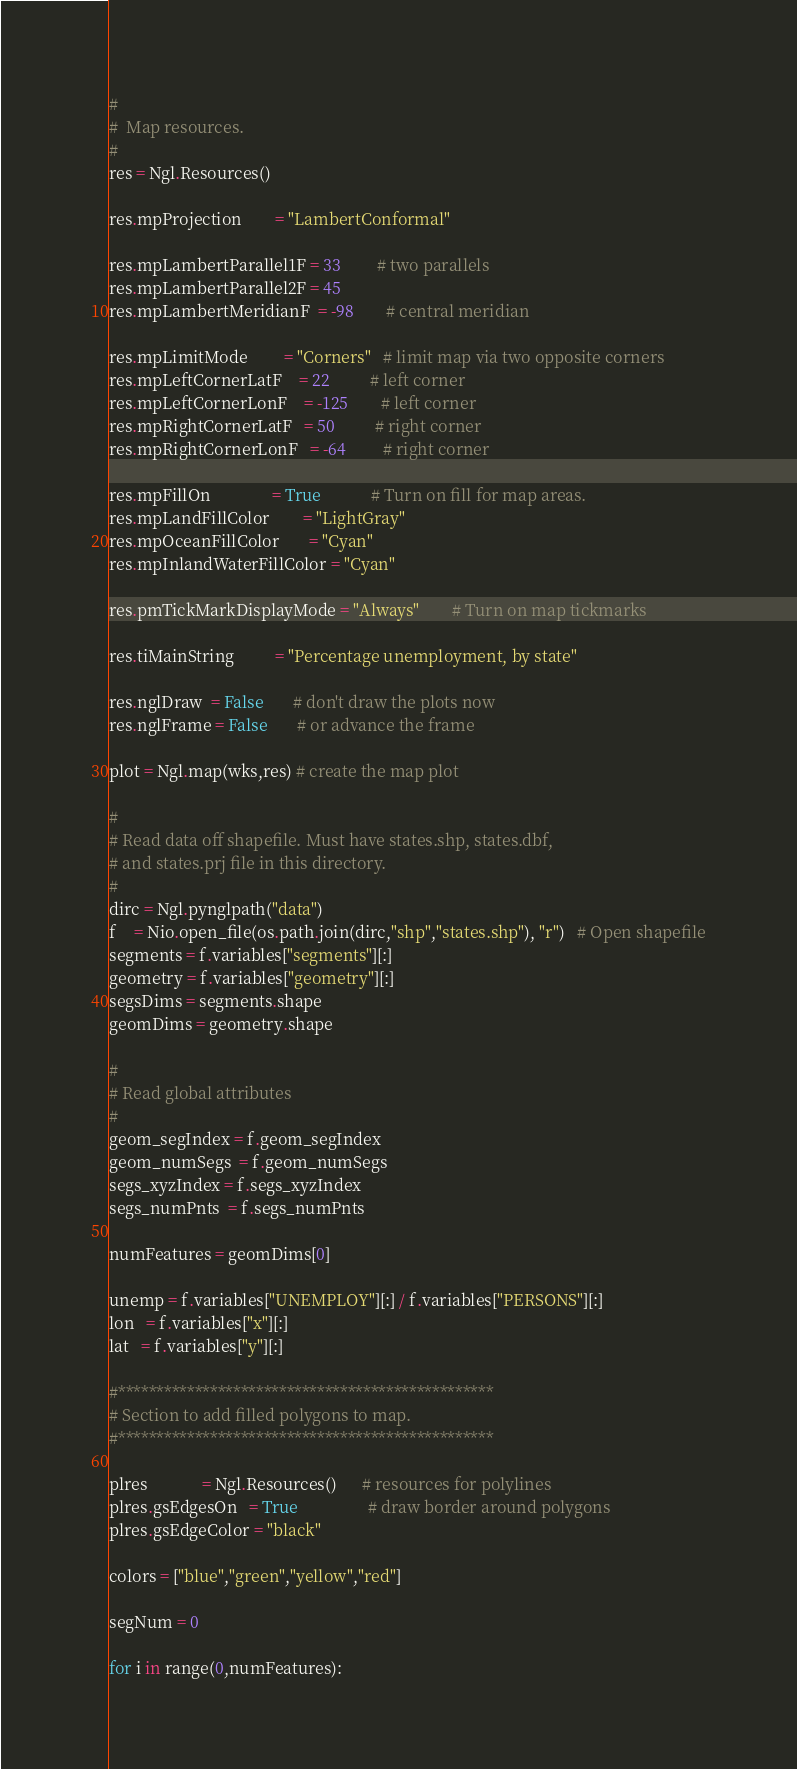<code> <loc_0><loc_0><loc_500><loc_500><_Python_>
#
#  Map resources.
#
res = Ngl.Resources()

res.mpProjection        = "LambertConformal"

res.mpLambertParallel1F = 33         # two parallels
res.mpLambertParallel2F = 45
res.mpLambertMeridianF  = -98        # central meridian

res.mpLimitMode         = "Corners"   # limit map via two opposite corners
res.mpLeftCornerLatF    = 22          # left corner
res.mpLeftCornerLonF    = -125        # left corner
res.mpRightCornerLatF   = 50          # right corner
res.mpRightCornerLonF   = -64         # right corner

res.mpFillOn               = True            # Turn on fill for map areas.
res.mpLandFillColor        = "LightGray"
res.mpOceanFillColor       = "Cyan"
res.mpInlandWaterFillColor = "Cyan"

res.pmTickMarkDisplayMode = "Always"        # Turn on map tickmarks

res.tiMainString          = "Percentage unemployment, by state"

res.nglDraw  = False       # don't draw the plots now
res.nglFrame = False       # or advance the frame

plot = Ngl.map(wks,res) # create the map plot

#
# Read data off shapefile. Must have states.shp, states.dbf,
# and states.prj file in this directory.
#
dirc = Ngl.pynglpath("data")
f    = Nio.open_file(os.path.join(dirc,"shp","states.shp"), "r")   # Open shapefile
segments = f.variables["segments"][:]
geometry = f.variables["geometry"][:]
segsDims = segments.shape
geomDims = geometry.shape

#
# Read global attributes  
#
geom_segIndex = f.geom_segIndex
geom_numSegs  = f.geom_numSegs
segs_xyzIndex = f.segs_xyzIndex
segs_numPnts  = f.segs_numPnts

numFeatures = geomDims[0]

unemp = f.variables["UNEMPLOY"][:] / f.variables["PERSONS"][:]
lon   = f.variables["x"][:]
lat   = f.variables["y"][:]

#*************************************************
# Section to add filled polygons to map.
#*************************************************

plres             = Ngl.Resources()      # resources for polylines
plres.gsEdgesOn   = True                 # draw border around polygons
plres.gsEdgeColor = "black"    

colors = ["blue","green","yellow","red"]

segNum = 0

for i in range(0,numFeatures):</code> 